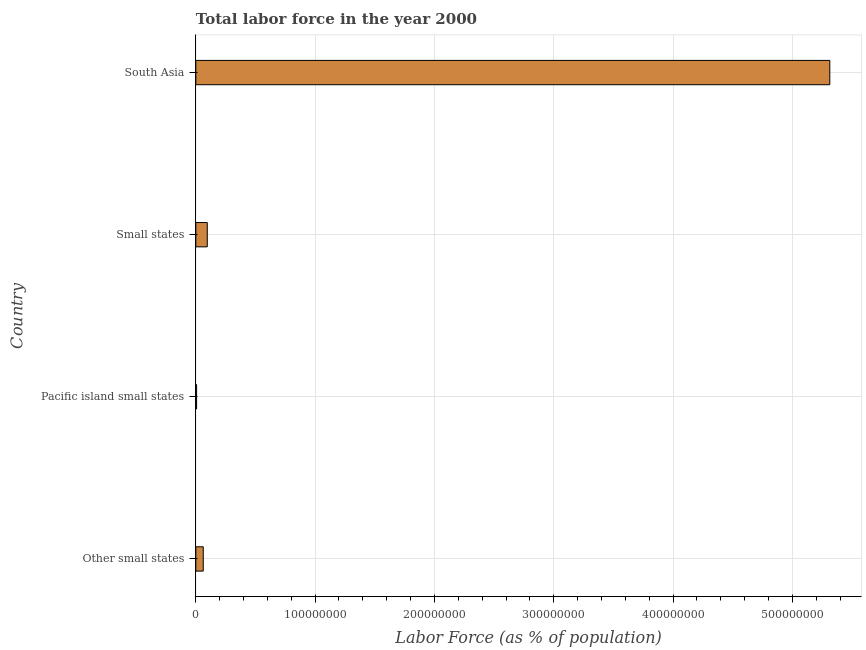Does the graph contain any zero values?
Provide a short and direct response. No. What is the title of the graph?
Offer a very short reply. Total labor force in the year 2000. What is the label or title of the X-axis?
Keep it short and to the point. Labor Force (as % of population). What is the total labor force in Pacific island small states?
Your response must be concise. 6.37e+05. Across all countries, what is the maximum total labor force?
Provide a short and direct response. 5.31e+08. Across all countries, what is the minimum total labor force?
Provide a succinct answer. 6.37e+05. In which country was the total labor force maximum?
Offer a very short reply. South Asia. In which country was the total labor force minimum?
Give a very brief answer. Pacific island small states. What is the sum of the total labor force?
Your response must be concise. 5.48e+08. What is the difference between the total labor force in Other small states and Small states?
Provide a short and direct response. -3.37e+06. What is the average total labor force per country?
Provide a short and direct response. 1.37e+08. What is the median total labor force?
Offer a very short reply. 7.90e+06. What is the ratio of the total labor force in Other small states to that in Pacific island small states?
Offer a very short reply. 9.76. Is the difference between the total labor force in Other small states and South Asia greater than the difference between any two countries?
Your response must be concise. No. What is the difference between the highest and the second highest total labor force?
Ensure brevity in your answer.  5.22e+08. Is the sum of the total labor force in Other small states and Small states greater than the maximum total labor force across all countries?
Your answer should be compact. No. What is the difference between the highest and the lowest total labor force?
Your answer should be very brief. 5.31e+08. In how many countries, is the total labor force greater than the average total labor force taken over all countries?
Ensure brevity in your answer.  1. How many bars are there?
Make the answer very short. 4. Are all the bars in the graph horizontal?
Provide a succinct answer. Yes. What is the difference between two consecutive major ticks on the X-axis?
Your answer should be very brief. 1.00e+08. Are the values on the major ticks of X-axis written in scientific E-notation?
Ensure brevity in your answer.  No. What is the Labor Force (as % of population) of Other small states?
Your answer should be very brief. 6.22e+06. What is the Labor Force (as % of population) of Pacific island small states?
Offer a very short reply. 6.37e+05. What is the Labor Force (as % of population) of Small states?
Make the answer very short. 9.59e+06. What is the Labor Force (as % of population) in South Asia?
Ensure brevity in your answer.  5.31e+08. What is the difference between the Labor Force (as % of population) in Other small states and Pacific island small states?
Offer a very short reply. 5.58e+06. What is the difference between the Labor Force (as % of population) in Other small states and Small states?
Offer a terse response. -3.37e+06. What is the difference between the Labor Force (as % of population) in Other small states and South Asia?
Your answer should be compact. -5.25e+08. What is the difference between the Labor Force (as % of population) in Pacific island small states and Small states?
Keep it short and to the point. -8.95e+06. What is the difference between the Labor Force (as % of population) in Pacific island small states and South Asia?
Your answer should be compact. -5.31e+08. What is the difference between the Labor Force (as % of population) in Small states and South Asia?
Offer a terse response. -5.22e+08. What is the ratio of the Labor Force (as % of population) in Other small states to that in Pacific island small states?
Ensure brevity in your answer.  9.76. What is the ratio of the Labor Force (as % of population) in Other small states to that in Small states?
Ensure brevity in your answer.  0.65. What is the ratio of the Labor Force (as % of population) in Other small states to that in South Asia?
Your answer should be very brief. 0.01. What is the ratio of the Labor Force (as % of population) in Pacific island small states to that in Small states?
Your answer should be very brief. 0.07. What is the ratio of the Labor Force (as % of population) in Small states to that in South Asia?
Provide a succinct answer. 0.02. 